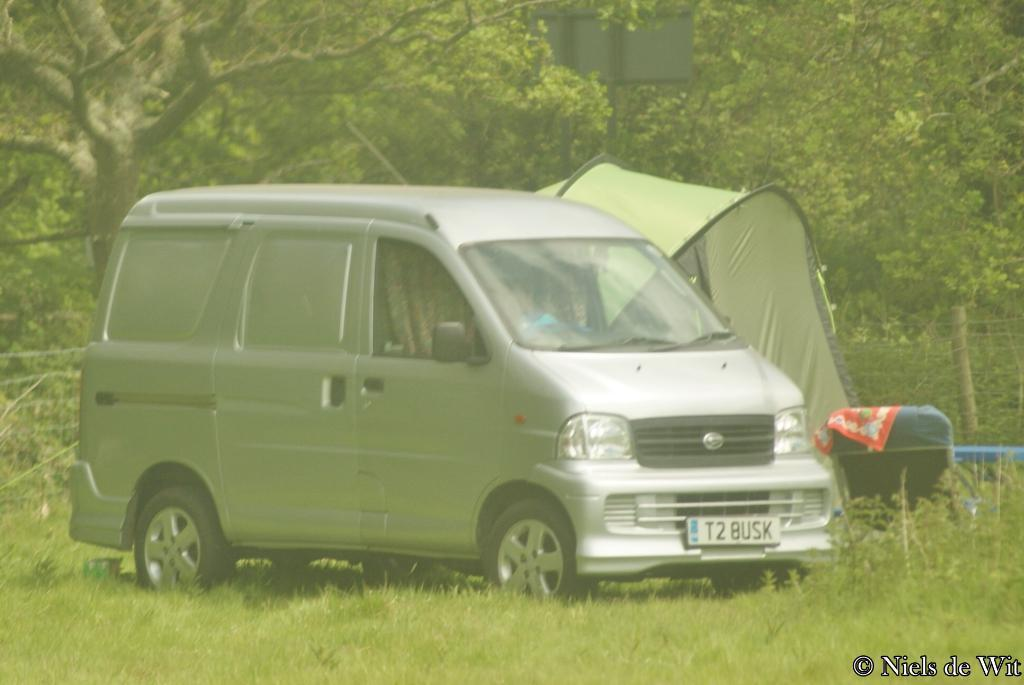<image>
Describe the image concisely. A silver colored van with the license plate "T2 BUSK" sits in a field. 